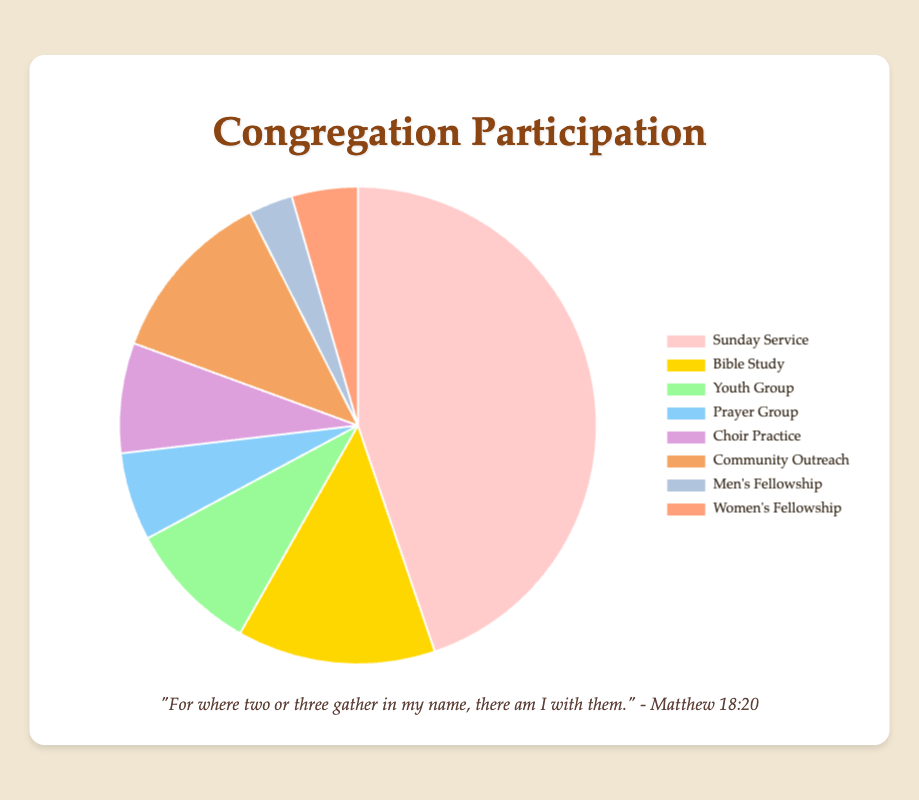What percentage of participants are involved in Bible Study? To find the percentage, first identify the number of participants in Bible Study (45). Then, sum the total number of participants across all activities (150 + 45 + 30 + 20 + 25 + 40 + 10 + 15 = 335). The percentage is then (45 / 335) * 100.
Answer: 13.4% Which activity has the highest participation? By simply looking at the dataset, you can see that the Sunday Service has the highest number of participants, with 150.
Answer: Sunday Service How many more participants are there in Sunday Service compared to Youth Group? Subtract the number of participants in Youth Group (30) from the number in Sunday Service (150). 150 - 30 = 120
Answer: 120 Which activity has the least number of participants? From the data, Men's Fellowship has the least participants, with 10.
Answer: Men's Fellowship What is the combined percentage of participants in Choir Practice and Community Outreach? First, add the number of participants in Choir Practice (25) and Community Outreach (40). The sum is 65. Then, find the total number of participants (335). Finally, calculate the percentage: (65 / 335) * 100.
Answer: 19.4% How does the participation in Women's Fellowship compare to that in Men's Fellowship? Women's Fellowship has 15 participants, whereas Men's Fellowship has 10. Therefore, Women's Fellowship has more participants than Men's Fellowship.
Answer: Women's Fellowship has more participants What is the average number of participants per activity? Sum the total number of participants for all activities (335) and divide by the number of activities (8). 335 / 8 = 41.875
Answer: 41.875 Which activity represents the smallest percentage of the total participation? Look for the smallest number of participants, which is Men's Fellowship with 10. Calculate the percentage: (10 / 335) * 100.
Answer: 3% What percentage do Youth Group and Prayer Group together represent of the total participation? First, sum the participants for Youth Group (30) and Prayer Group (20). The total is 50. Then, find the percentage: (50 / 335) * 100.
Answer: 14.9% Which activity is represented by the light blue section of the pie chart? The color light blue on the pie chart corresponds to Youth Group, which has 30 participants.
Answer: Youth Group 